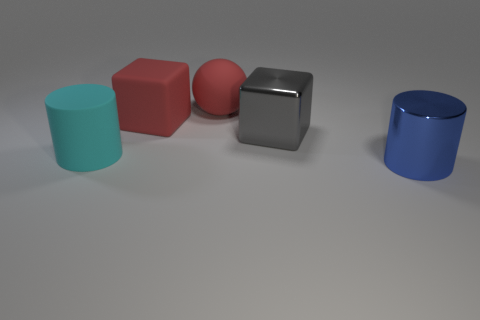The shiny object that is to the left of the metallic object on the right side of the gray metallic thing is what shape?
Offer a very short reply. Cube. What is the shape of the big gray metal thing?
Give a very brief answer. Cube. What is the big sphere that is to the left of the cylinder right of the large metallic object left of the large blue cylinder made of?
Provide a short and direct response. Rubber. What number of other things are there of the same material as the big gray thing
Offer a terse response. 1. There is a large cylinder that is to the right of the big rubber block; how many metallic things are right of it?
Offer a terse response. 0. What number of spheres are either big gray shiny things or shiny objects?
Your answer should be compact. 0. There is a object that is both in front of the big metallic cube and to the left of the big blue thing; what is its color?
Give a very brief answer. Cyan. Is there anything else of the same color as the big rubber block?
Give a very brief answer. Yes. The large thing that is in front of the large cylinder behind the blue thing is what color?
Your response must be concise. Blue. Is the size of the gray metallic cube the same as the red matte sphere?
Give a very brief answer. Yes. 